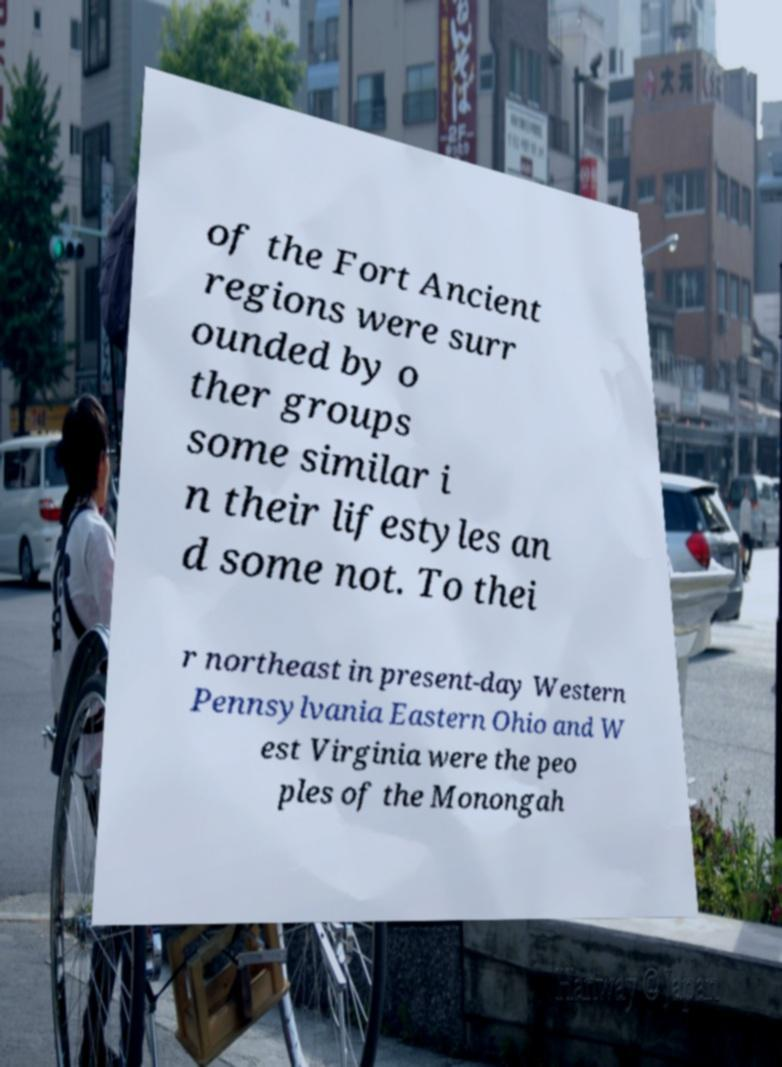Could you assist in decoding the text presented in this image and type it out clearly? of the Fort Ancient regions were surr ounded by o ther groups some similar i n their lifestyles an d some not. To thei r northeast in present-day Western Pennsylvania Eastern Ohio and W est Virginia were the peo ples of the Monongah 